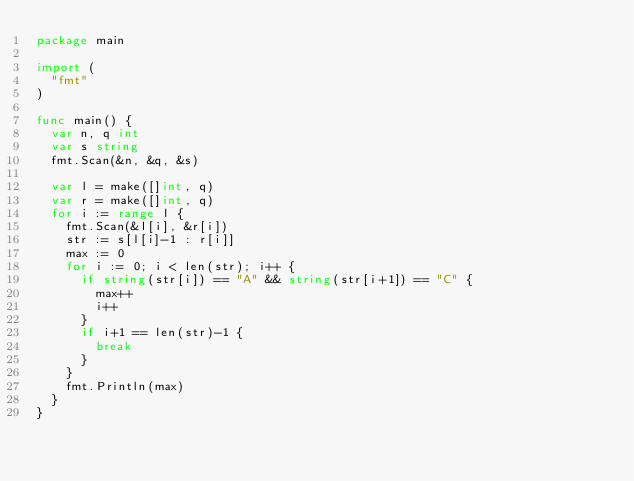<code> <loc_0><loc_0><loc_500><loc_500><_Go_>package main

import (
	"fmt"
)

func main() {
	var n, q int
	var s string
	fmt.Scan(&n, &q, &s)

	var l = make([]int, q)
	var r = make([]int, q)
	for i := range l {
		fmt.Scan(&l[i], &r[i])
		str := s[l[i]-1 : r[i]]
		max := 0
		for i := 0; i < len(str); i++ {
			if string(str[i]) == "A" && string(str[i+1]) == "C" {
				max++
				i++
			}
			if i+1 == len(str)-1 {
				break
			}
		}
		fmt.Println(max)
	}
}</code> 